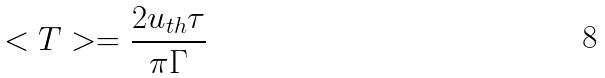<formula> <loc_0><loc_0><loc_500><loc_500>< T > = \frac { 2 u _ { t h } \tau } { \pi \Gamma }</formula> 